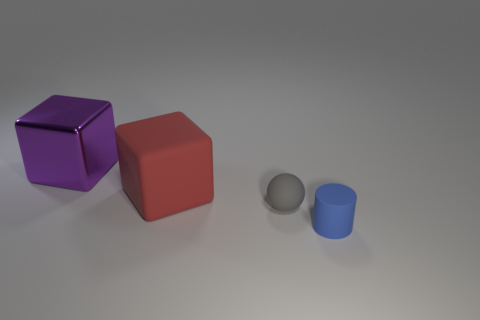Are there any large purple shiny blocks?
Ensure brevity in your answer.  Yes. Are there an equal number of small blue rubber cylinders and tiny brown metal blocks?
Offer a terse response. No. How many shiny things are the same color as the metal block?
Your answer should be very brief. 0. Are the sphere and the block that is on the left side of the big red block made of the same material?
Make the answer very short. No. Are there more large shiny things on the left side of the small gray matte object than gray rubber balls?
Give a very brief answer. No. Is there any other thing that has the same size as the red rubber thing?
Offer a terse response. Yes. There is a sphere; is it the same color as the thing in front of the sphere?
Give a very brief answer. No. Are there the same number of red blocks behind the large purple metallic object and red rubber cubes that are on the right side of the large matte cube?
Offer a very short reply. Yes. There is a thing in front of the small gray matte sphere; what is it made of?
Offer a very short reply. Rubber. How many things are blocks on the left side of the red matte thing or large brown shiny balls?
Keep it short and to the point. 1. 